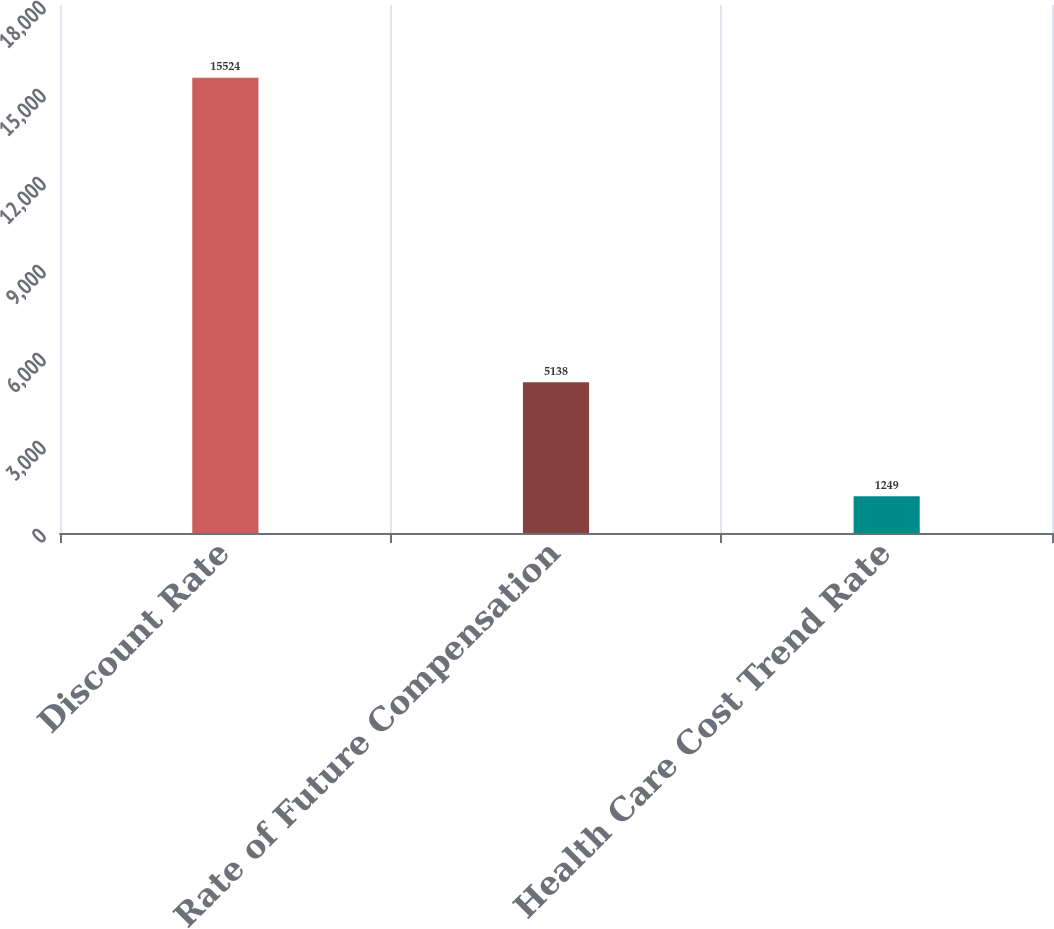Convert chart. <chart><loc_0><loc_0><loc_500><loc_500><bar_chart><fcel>Discount Rate<fcel>Rate of Future Compensation<fcel>Health Care Cost Trend Rate<nl><fcel>15524<fcel>5138<fcel>1249<nl></chart> 